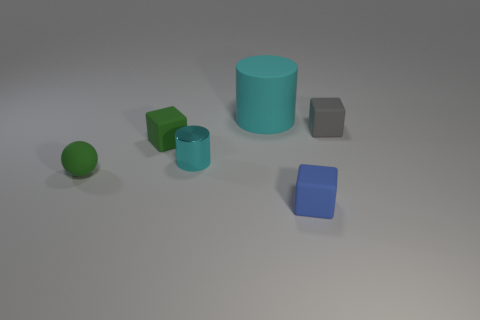Add 4 green cubes. How many objects exist? 10 Subtract all cylinders. How many objects are left? 4 Add 4 small green balls. How many small green balls are left? 5 Add 4 small metal spheres. How many small metal spheres exist? 4 Subtract 0 red cubes. How many objects are left? 6 Subtract all cyan metallic cylinders. Subtract all cyan matte things. How many objects are left? 4 